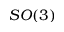Convert formula to latex. <formula><loc_0><loc_0><loc_500><loc_500>S O ( 3 )</formula> 